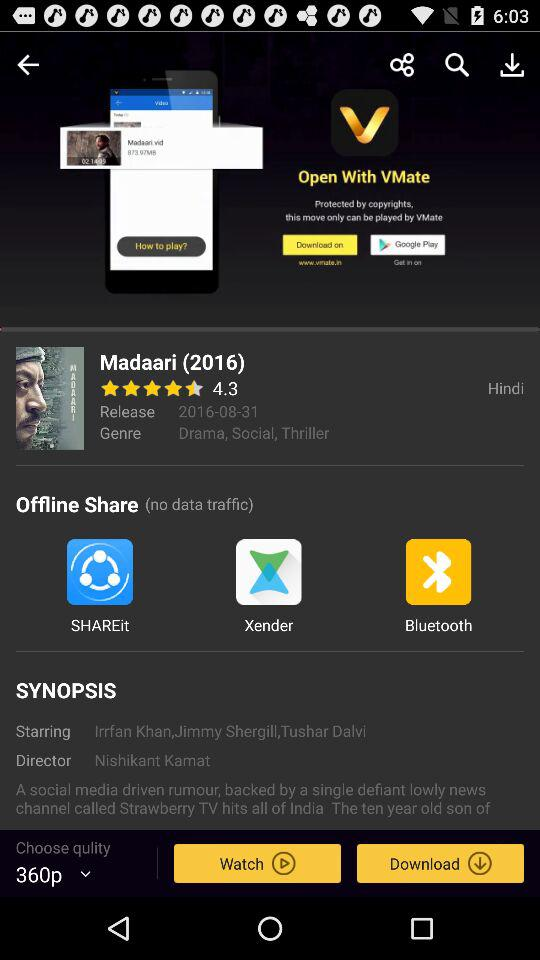What is the date of release? The date of release is August 31, 2016. 